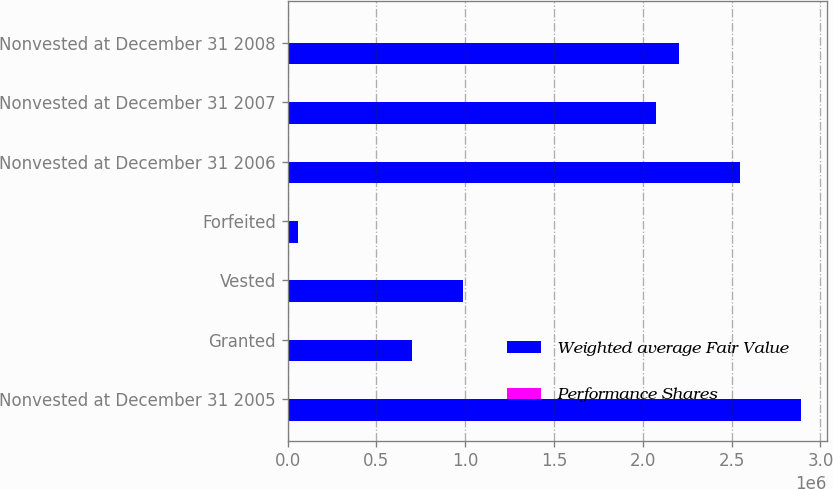<chart> <loc_0><loc_0><loc_500><loc_500><stacked_bar_chart><ecel><fcel>Nonvested at December 31 2005<fcel>Granted<fcel>Vested<fcel>Forfeited<fcel>Nonvested at December 31 2006<fcel>Nonvested at December 31 2007<fcel>Nonvested at December 31 2008<nl><fcel>Weighted average Fair Value<fcel>2.8906e+06<fcel>700592<fcel>987200<fcel>58812<fcel>2.54518e+06<fcel>2.07464e+06<fcel>2.20649e+06<nl><fcel>Performance Shares<fcel>14.07<fcel>24.72<fcel>12.01<fcel>14.03<fcel>17.8<fcel>26.34<fcel>32.98<nl></chart> 